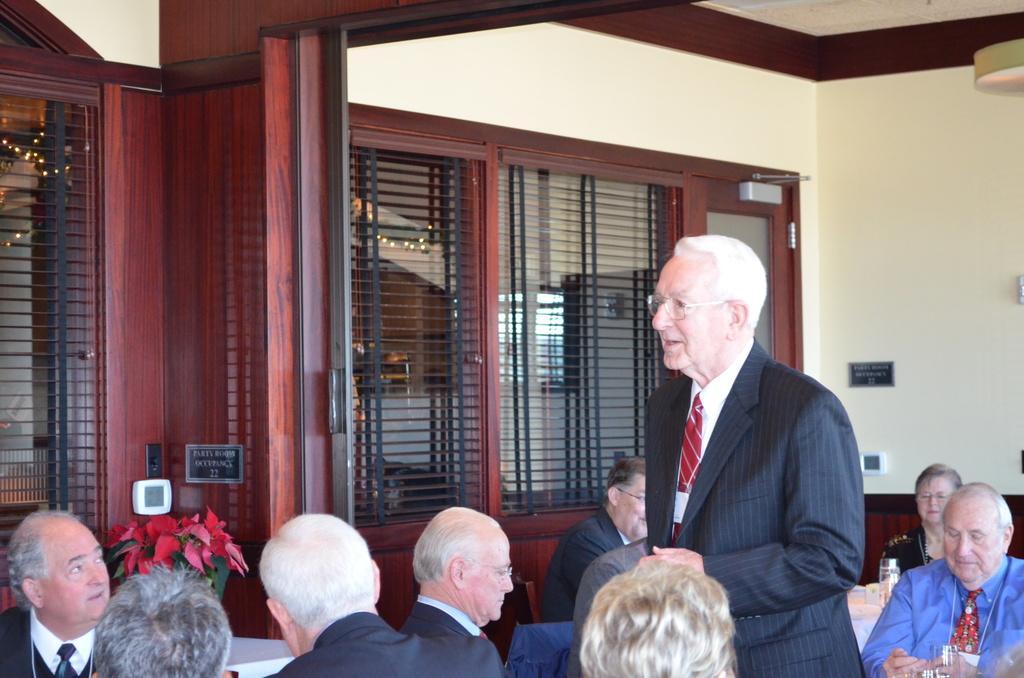How would you summarize this image in a sentence or two? This image is taken indoors. At the bottom of the image a few people are sitting on the chairs and there are a few tables with tablecloths and a few things on them and a man is standing on the floor. In the background there is a wall with a door and windows. There are two boards with text on them. At the top of the image there is a ceiling. 